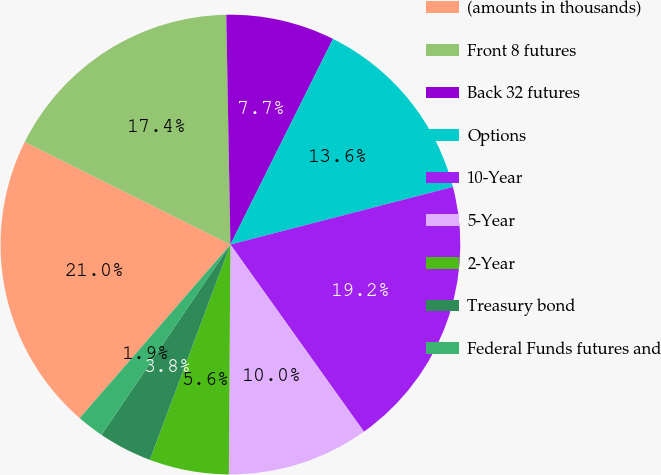Convert chart. <chart><loc_0><loc_0><loc_500><loc_500><pie_chart><fcel>(amounts in thousands)<fcel>Front 8 futures<fcel>Back 32 futures<fcel>Options<fcel>10-Year<fcel>5-Year<fcel>2-Year<fcel>Treasury bond<fcel>Federal Funds futures and<nl><fcel>20.98%<fcel>17.35%<fcel>7.65%<fcel>13.6%<fcel>19.17%<fcel>9.97%<fcel>5.59%<fcel>3.78%<fcel>1.9%<nl></chart> 